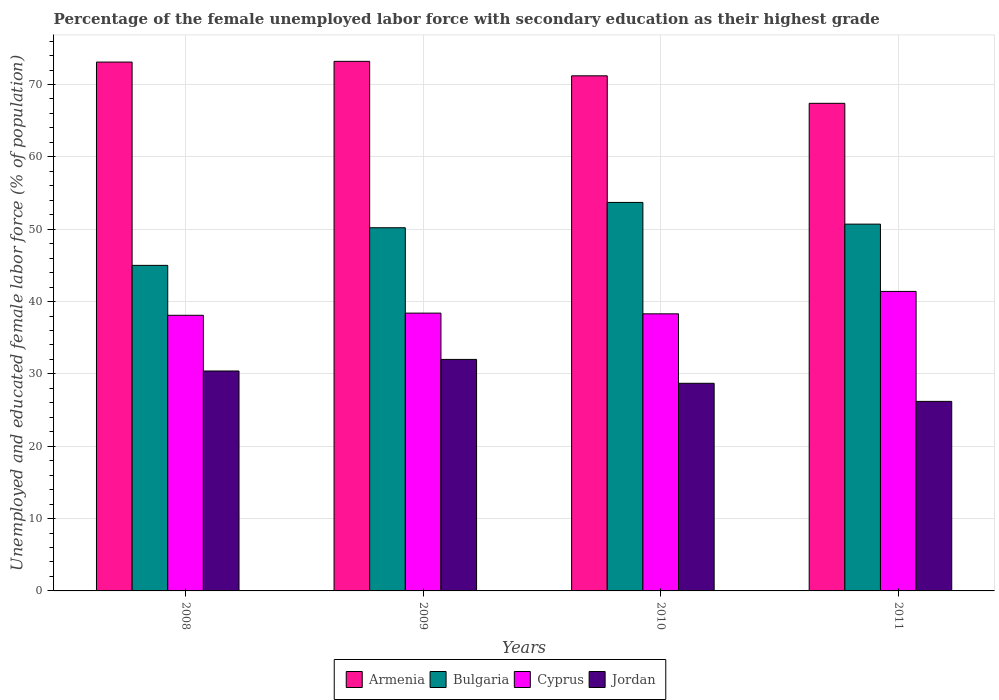Are the number of bars on each tick of the X-axis equal?
Your response must be concise. Yes. In how many cases, is the number of bars for a given year not equal to the number of legend labels?
Your response must be concise. 0. What is the percentage of the unemployed female labor force with secondary education in Cyprus in 2008?
Ensure brevity in your answer.  38.1. Across all years, what is the maximum percentage of the unemployed female labor force with secondary education in Cyprus?
Your response must be concise. 41.4. Across all years, what is the minimum percentage of the unemployed female labor force with secondary education in Armenia?
Your answer should be compact. 67.4. In which year was the percentage of the unemployed female labor force with secondary education in Bulgaria maximum?
Provide a succinct answer. 2010. In which year was the percentage of the unemployed female labor force with secondary education in Bulgaria minimum?
Offer a terse response. 2008. What is the total percentage of the unemployed female labor force with secondary education in Cyprus in the graph?
Make the answer very short. 156.2. What is the difference between the percentage of the unemployed female labor force with secondary education in Armenia in 2009 and that in 2011?
Provide a short and direct response. 5.8. What is the difference between the percentage of the unemployed female labor force with secondary education in Jordan in 2011 and the percentage of the unemployed female labor force with secondary education in Cyprus in 2009?
Make the answer very short. -12.2. What is the average percentage of the unemployed female labor force with secondary education in Bulgaria per year?
Make the answer very short. 49.9. In the year 2010, what is the difference between the percentage of the unemployed female labor force with secondary education in Jordan and percentage of the unemployed female labor force with secondary education in Armenia?
Provide a succinct answer. -42.5. What is the ratio of the percentage of the unemployed female labor force with secondary education in Jordan in 2008 to that in 2010?
Provide a succinct answer. 1.06. Is the percentage of the unemployed female labor force with secondary education in Armenia in 2010 less than that in 2011?
Keep it short and to the point. No. What is the difference between the highest and the second highest percentage of the unemployed female labor force with secondary education in Jordan?
Make the answer very short. 1.6. What is the difference between the highest and the lowest percentage of the unemployed female labor force with secondary education in Jordan?
Your response must be concise. 5.8. Is the sum of the percentage of the unemployed female labor force with secondary education in Cyprus in 2008 and 2010 greater than the maximum percentage of the unemployed female labor force with secondary education in Bulgaria across all years?
Offer a very short reply. Yes. What does the 4th bar from the left in 2010 represents?
Your response must be concise. Jordan. What does the 3rd bar from the right in 2009 represents?
Your answer should be very brief. Bulgaria. How many bars are there?
Ensure brevity in your answer.  16. Are all the bars in the graph horizontal?
Offer a very short reply. No. What is the difference between two consecutive major ticks on the Y-axis?
Provide a short and direct response. 10. Are the values on the major ticks of Y-axis written in scientific E-notation?
Give a very brief answer. No. Does the graph contain any zero values?
Provide a succinct answer. No. What is the title of the graph?
Offer a terse response. Percentage of the female unemployed labor force with secondary education as their highest grade. What is the label or title of the Y-axis?
Keep it short and to the point. Unemployed and educated female labor force (% of population). What is the Unemployed and educated female labor force (% of population) of Armenia in 2008?
Your response must be concise. 73.1. What is the Unemployed and educated female labor force (% of population) of Cyprus in 2008?
Your answer should be compact. 38.1. What is the Unemployed and educated female labor force (% of population) in Jordan in 2008?
Your answer should be very brief. 30.4. What is the Unemployed and educated female labor force (% of population) in Armenia in 2009?
Make the answer very short. 73.2. What is the Unemployed and educated female labor force (% of population) of Bulgaria in 2009?
Offer a very short reply. 50.2. What is the Unemployed and educated female labor force (% of population) in Cyprus in 2009?
Make the answer very short. 38.4. What is the Unemployed and educated female labor force (% of population) in Armenia in 2010?
Offer a terse response. 71.2. What is the Unemployed and educated female labor force (% of population) of Bulgaria in 2010?
Offer a very short reply. 53.7. What is the Unemployed and educated female labor force (% of population) in Cyprus in 2010?
Provide a short and direct response. 38.3. What is the Unemployed and educated female labor force (% of population) in Jordan in 2010?
Make the answer very short. 28.7. What is the Unemployed and educated female labor force (% of population) of Armenia in 2011?
Provide a succinct answer. 67.4. What is the Unemployed and educated female labor force (% of population) of Bulgaria in 2011?
Provide a short and direct response. 50.7. What is the Unemployed and educated female labor force (% of population) of Cyprus in 2011?
Give a very brief answer. 41.4. What is the Unemployed and educated female labor force (% of population) in Jordan in 2011?
Provide a succinct answer. 26.2. Across all years, what is the maximum Unemployed and educated female labor force (% of population) in Armenia?
Make the answer very short. 73.2. Across all years, what is the maximum Unemployed and educated female labor force (% of population) of Bulgaria?
Offer a terse response. 53.7. Across all years, what is the maximum Unemployed and educated female labor force (% of population) in Cyprus?
Your answer should be very brief. 41.4. Across all years, what is the minimum Unemployed and educated female labor force (% of population) in Armenia?
Your response must be concise. 67.4. Across all years, what is the minimum Unemployed and educated female labor force (% of population) of Bulgaria?
Give a very brief answer. 45. Across all years, what is the minimum Unemployed and educated female labor force (% of population) of Cyprus?
Ensure brevity in your answer.  38.1. Across all years, what is the minimum Unemployed and educated female labor force (% of population) in Jordan?
Offer a terse response. 26.2. What is the total Unemployed and educated female labor force (% of population) in Armenia in the graph?
Keep it short and to the point. 284.9. What is the total Unemployed and educated female labor force (% of population) of Bulgaria in the graph?
Provide a short and direct response. 199.6. What is the total Unemployed and educated female labor force (% of population) in Cyprus in the graph?
Your answer should be very brief. 156.2. What is the total Unemployed and educated female labor force (% of population) in Jordan in the graph?
Offer a terse response. 117.3. What is the difference between the Unemployed and educated female labor force (% of population) in Bulgaria in 2008 and that in 2009?
Your answer should be compact. -5.2. What is the difference between the Unemployed and educated female labor force (% of population) of Armenia in 2008 and that in 2010?
Provide a succinct answer. 1.9. What is the difference between the Unemployed and educated female labor force (% of population) in Bulgaria in 2008 and that in 2010?
Offer a terse response. -8.7. What is the difference between the Unemployed and educated female labor force (% of population) in Jordan in 2008 and that in 2010?
Your answer should be very brief. 1.7. What is the difference between the Unemployed and educated female labor force (% of population) of Jordan in 2008 and that in 2011?
Your answer should be very brief. 4.2. What is the difference between the Unemployed and educated female labor force (% of population) in Armenia in 2009 and that in 2010?
Offer a terse response. 2. What is the difference between the Unemployed and educated female labor force (% of population) of Bulgaria in 2009 and that in 2010?
Make the answer very short. -3.5. What is the difference between the Unemployed and educated female labor force (% of population) of Jordan in 2009 and that in 2010?
Ensure brevity in your answer.  3.3. What is the difference between the Unemployed and educated female labor force (% of population) in Armenia in 2009 and that in 2011?
Provide a short and direct response. 5.8. What is the difference between the Unemployed and educated female labor force (% of population) of Bulgaria in 2009 and that in 2011?
Provide a short and direct response. -0.5. What is the difference between the Unemployed and educated female labor force (% of population) of Jordan in 2009 and that in 2011?
Offer a terse response. 5.8. What is the difference between the Unemployed and educated female labor force (% of population) of Armenia in 2008 and the Unemployed and educated female labor force (% of population) of Bulgaria in 2009?
Provide a succinct answer. 22.9. What is the difference between the Unemployed and educated female labor force (% of population) in Armenia in 2008 and the Unemployed and educated female labor force (% of population) in Cyprus in 2009?
Provide a short and direct response. 34.7. What is the difference between the Unemployed and educated female labor force (% of population) of Armenia in 2008 and the Unemployed and educated female labor force (% of population) of Jordan in 2009?
Give a very brief answer. 41.1. What is the difference between the Unemployed and educated female labor force (% of population) in Bulgaria in 2008 and the Unemployed and educated female labor force (% of population) in Cyprus in 2009?
Your response must be concise. 6.6. What is the difference between the Unemployed and educated female labor force (% of population) in Armenia in 2008 and the Unemployed and educated female labor force (% of population) in Cyprus in 2010?
Ensure brevity in your answer.  34.8. What is the difference between the Unemployed and educated female labor force (% of population) of Armenia in 2008 and the Unemployed and educated female labor force (% of population) of Jordan in 2010?
Provide a short and direct response. 44.4. What is the difference between the Unemployed and educated female labor force (% of population) in Bulgaria in 2008 and the Unemployed and educated female labor force (% of population) in Cyprus in 2010?
Ensure brevity in your answer.  6.7. What is the difference between the Unemployed and educated female labor force (% of population) of Armenia in 2008 and the Unemployed and educated female labor force (% of population) of Bulgaria in 2011?
Make the answer very short. 22.4. What is the difference between the Unemployed and educated female labor force (% of population) in Armenia in 2008 and the Unemployed and educated female labor force (% of population) in Cyprus in 2011?
Offer a very short reply. 31.7. What is the difference between the Unemployed and educated female labor force (% of population) in Armenia in 2008 and the Unemployed and educated female labor force (% of population) in Jordan in 2011?
Ensure brevity in your answer.  46.9. What is the difference between the Unemployed and educated female labor force (% of population) of Armenia in 2009 and the Unemployed and educated female labor force (% of population) of Bulgaria in 2010?
Keep it short and to the point. 19.5. What is the difference between the Unemployed and educated female labor force (% of population) of Armenia in 2009 and the Unemployed and educated female labor force (% of population) of Cyprus in 2010?
Your answer should be compact. 34.9. What is the difference between the Unemployed and educated female labor force (% of population) in Armenia in 2009 and the Unemployed and educated female labor force (% of population) in Jordan in 2010?
Offer a terse response. 44.5. What is the difference between the Unemployed and educated female labor force (% of population) in Bulgaria in 2009 and the Unemployed and educated female labor force (% of population) in Cyprus in 2010?
Provide a succinct answer. 11.9. What is the difference between the Unemployed and educated female labor force (% of population) in Cyprus in 2009 and the Unemployed and educated female labor force (% of population) in Jordan in 2010?
Keep it short and to the point. 9.7. What is the difference between the Unemployed and educated female labor force (% of population) of Armenia in 2009 and the Unemployed and educated female labor force (% of population) of Bulgaria in 2011?
Keep it short and to the point. 22.5. What is the difference between the Unemployed and educated female labor force (% of population) in Armenia in 2009 and the Unemployed and educated female labor force (% of population) in Cyprus in 2011?
Give a very brief answer. 31.8. What is the difference between the Unemployed and educated female labor force (% of population) of Bulgaria in 2009 and the Unemployed and educated female labor force (% of population) of Jordan in 2011?
Your answer should be very brief. 24. What is the difference between the Unemployed and educated female labor force (% of population) of Armenia in 2010 and the Unemployed and educated female labor force (% of population) of Bulgaria in 2011?
Keep it short and to the point. 20.5. What is the difference between the Unemployed and educated female labor force (% of population) in Armenia in 2010 and the Unemployed and educated female labor force (% of population) in Cyprus in 2011?
Provide a succinct answer. 29.8. What is the difference between the Unemployed and educated female labor force (% of population) in Armenia in 2010 and the Unemployed and educated female labor force (% of population) in Jordan in 2011?
Provide a succinct answer. 45. What is the difference between the Unemployed and educated female labor force (% of population) in Bulgaria in 2010 and the Unemployed and educated female labor force (% of population) in Cyprus in 2011?
Provide a succinct answer. 12.3. What is the difference between the Unemployed and educated female labor force (% of population) in Bulgaria in 2010 and the Unemployed and educated female labor force (% of population) in Jordan in 2011?
Offer a very short reply. 27.5. What is the difference between the Unemployed and educated female labor force (% of population) in Cyprus in 2010 and the Unemployed and educated female labor force (% of population) in Jordan in 2011?
Offer a very short reply. 12.1. What is the average Unemployed and educated female labor force (% of population) of Armenia per year?
Your answer should be compact. 71.22. What is the average Unemployed and educated female labor force (% of population) in Bulgaria per year?
Your response must be concise. 49.9. What is the average Unemployed and educated female labor force (% of population) of Cyprus per year?
Provide a succinct answer. 39.05. What is the average Unemployed and educated female labor force (% of population) of Jordan per year?
Keep it short and to the point. 29.32. In the year 2008, what is the difference between the Unemployed and educated female labor force (% of population) of Armenia and Unemployed and educated female labor force (% of population) of Bulgaria?
Provide a short and direct response. 28.1. In the year 2008, what is the difference between the Unemployed and educated female labor force (% of population) of Armenia and Unemployed and educated female labor force (% of population) of Jordan?
Provide a short and direct response. 42.7. In the year 2008, what is the difference between the Unemployed and educated female labor force (% of population) of Bulgaria and Unemployed and educated female labor force (% of population) of Jordan?
Your answer should be compact. 14.6. In the year 2009, what is the difference between the Unemployed and educated female labor force (% of population) in Armenia and Unemployed and educated female labor force (% of population) in Cyprus?
Keep it short and to the point. 34.8. In the year 2009, what is the difference between the Unemployed and educated female labor force (% of population) in Armenia and Unemployed and educated female labor force (% of population) in Jordan?
Ensure brevity in your answer.  41.2. In the year 2009, what is the difference between the Unemployed and educated female labor force (% of population) in Bulgaria and Unemployed and educated female labor force (% of population) in Cyprus?
Provide a short and direct response. 11.8. In the year 2009, what is the difference between the Unemployed and educated female labor force (% of population) in Bulgaria and Unemployed and educated female labor force (% of population) in Jordan?
Offer a very short reply. 18.2. In the year 2009, what is the difference between the Unemployed and educated female labor force (% of population) in Cyprus and Unemployed and educated female labor force (% of population) in Jordan?
Your answer should be compact. 6.4. In the year 2010, what is the difference between the Unemployed and educated female labor force (% of population) of Armenia and Unemployed and educated female labor force (% of population) of Cyprus?
Your response must be concise. 32.9. In the year 2010, what is the difference between the Unemployed and educated female labor force (% of population) in Armenia and Unemployed and educated female labor force (% of population) in Jordan?
Your answer should be very brief. 42.5. In the year 2010, what is the difference between the Unemployed and educated female labor force (% of population) of Cyprus and Unemployed and educated female labor force (% of population) of Jordan?
Give a very brief answer. 9.6. In the year 2011, what is the difference between the Unemployed and educated female labor force (% of population) in Armenia and Unemployed and educated female labor force (% of population) in Bulgaria?
Ensure brevity in your answer.  16.7. In the year 2011, what is the difference between the Unemployed and educated female labor force (% of population) in Armenia and Unemployed and educated female labor force (% of population) in Jordan?
Your response must be concise. 41.2. In the year 2011, what is the difference between the Unemployed and educated female labor force (% of population) in Bulgaria and Unemployed and educated female labor force (% of population) in Cyprus?
Provide a short and direct response. 9.3. In the year 2011, what is the difference between the Unemployed and educated female labor force (% of population) of Bulgaria and Unemployed and educated female labor force (% of population) of Jordan?
Offer a terse response. 24.5. What is the ratio of the Unemployed and educated female labor force (% of population) in Armenia in 2008 to that in 2009?
Offer a terse response. 1. What is the ratio of the Unemployed and educated female labor force (% of population) of Bulgaria in 2008 to that in 2009?
Provide a short and direct response. 0.9. What is the ratio of the Unemployed and educated female labor force (% of population) in Cyprus in 2008 to that in 2009?
Provide a short and direct response. 0.99. What is the ratio of the Unemployed and educated female labor force (% of population) of Jordan in 2008 to that in 2009?
Your answer should be very brief. 0.95. What is the ratio of the Unemployed and educated female labor force (% of population) in Armenia in 2008 to that in 2010?
Provide a succinct answer. 1.03. What is the ratio of the Unemployed and educated female labor force (% of population) in Bulgaria in 2008 to that in 2010?
Your response must be concise. 0.84. What is the ratio of the Unemployed and educated female labor force (% of population) of Cyprus in 2008 to that in 2010?
Ensure brevity in your answer.  0.99. What is the ratio of the Unemployed and educated female labor force (% of population) of Jordan in 2008 to that in 2010?
Your response must be concise. 1.06. What is the ratio of the Unemployed and educated female labor force (% of population) in Armenia in 2008 to that in 2011?
Offer a very short reply. 1.08. What is the ratio of the Unemployed and educated female labor force (% of population) in Bulgaria in 2008 to that in 2011?
Your response must be concise. 0.89. What is the ratio of the Unemployed and educated female labor force (% of population) of Cyprus in 2008 to that in 2011?
Your answer should be compact. 0.92. What is the ratio of the Unemployed and educated female labor force (% of population) in Jordan in 2008 to that in 2011?
Give a very brief answer. 1.16. What is the ratio of the Unemployed and educated female labor force (% of population) of Armenia in 2009 to that in 2010?
Provide a short and direct response. 1.03. What is the ratio of the Unemployed and educated female labor force (% of population) of Bulgaria in 2009 to that in 2010?
Your answer should be very brief. 0.93. What is the ratio of the Unemployed and educated female labor force (% of population) in Jordan in 2009 to that in 2010?
Your answer should be compact. 1.11. What is the ratio of the Unemployed and educated female labor force (% of population) in Armenia in 2009 to that in 2011?
Give a very brief answer. 1.09. What is the ratio of the Unemployed and educated female labor force (% of population) in Cyprus in 2009 to that in 2011?
Provide a succinct answer. 0.93. What is the ratio of the Unemployed and educated female labor force (% of population) of Jordan in 2009 to that in 2011?
Provide a short and direct response. 1.22. What is the ratio of the Unemployed and educated female labor force (% of population) in Armenia in 2010 to that in 2011?
Give a very brief answer. 1.06. What is the ratio of the Unemployed and educated female labor force (% of population) of Bulgaria in 2010 to that in 2011?
Offer a terse response. 1.06. What is the ratio of the Unemployed and educated female labor force (% of population) in Cyprus in 2010 to that in 2011?
Your response must be concise. 0.93. What is the ratio of the Unemployed and educated female labor force (% of population) of Jordan in 2010 to that in 2011?
Keep it short and to the point. 1.1. What is the difference between the highest and the second highest Unemployed and educated female labor force (% of population) in Armenia?
Give a very brief answer. 0.1. What is the difference between the highest and the second highest Unemployed and educated female labor force (% of population) of Bulgaria?
Keep it short and to the point. 3. What is the difference between the highest and the second highest Unemployed and educated female labor force (% of population) of Cyprus?
Offer a very short reply. 3. What is the difference between the highest and the lowest Unemployed and educated female labor force (% of population) in Armenia?
Make the answer very short. 5.8. What is the difference between the highest and the lowest Unemployed and educated female labor force (% of population) in Jordan?
Make the answer very short. 5.8. 